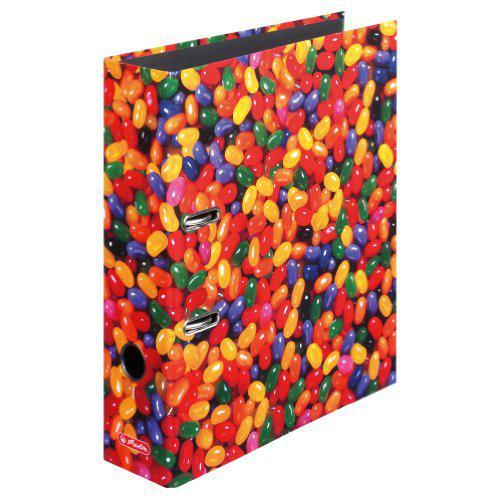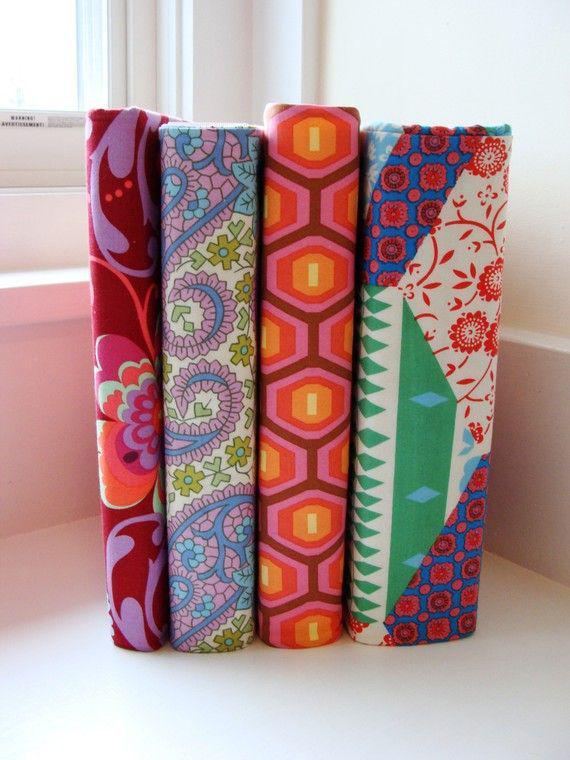The first image is the image on the left, the second image is the image on the right. Assess this claim about the two images: "One image shows exactly five binders displayed side-by-side.". Correct or not? Answer yes or no. No. The first image is the image on the left, the second image is the image on the right. For the images displayed, is the sentence "There is a single floral binder in the image on the right." factually correct? Answer yes or no. No. 